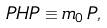<formula> <loc_0><loc_0><loc_500><loc_500>P H P \equiv m _ { 0 } \, P ,</formula> 